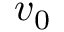Convert formula to latex. <formula><loc_0><loc_0><loc_500><loc_500>v _ { 0 }</formula> 